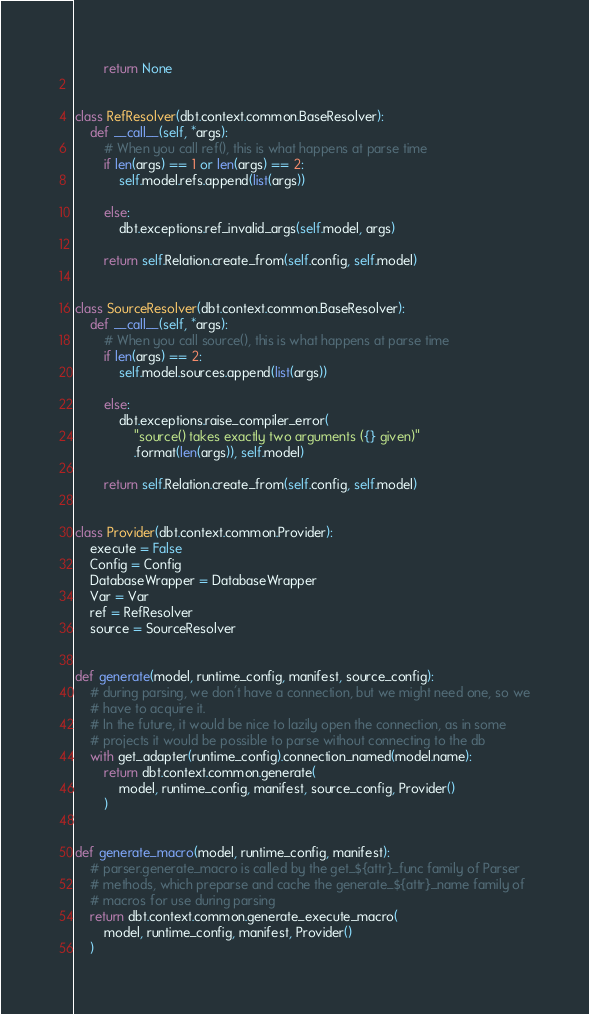Convert code to text. <code><loc_0><loc_0><loc_500><loc_500><_Python_>        return None


class RefResolver(dbt.context.common.BaseResolver):
    def __call__(self, *args):
        # When you call ref(), this is what happens at parse time
        if len(args) == 1 or len(args) == 2:
            self.model.refs.append(list(args))

        else:
            dbt.exceptions.ref_invalid_args(self.model, args)

        return self.Relation.create_from(self.config, self.model)


class SourceResolver(dbt.context.common.BaseResolver):
    def __call__(self, *args):
        # When you call source(), this is what happens at parse time
        if len(args) == 2:
            self.model.sources.append(list(args))

        else:
            dbt.exceptions.raise_compiler_error(
                "source() takes exactly two arguments ({} given)"
                .format(len(args)), self.model)

        return self.Relation.create_from(self.config, self.model)


class Provider(dbt.context.common.Provider):
    execute = False
    Config = Config
    DatabaseWrapper = DatabaseWrapper
    Var = Var
    ref = RefResolver
    source = SourceResolver


def generate(model, runtime_config, manifest, source_config):
    # during parsing, we don't have a connection, but we might need one, so we
    # have to acquire it.
    # In the future, it would be nice to lazily open the connection, as in some
    # projects it would be possible to parse without connecting to the db
    with get_adapter(runtime_config).connection_named(model.name):
        return dbt.context.common.generate(
            model, runtime_config, manifest, source_config, Provider()
        )


def generate_macro(model, runtime_config, manifest):
    # parser.generate_macro is called by the get_${attr}_func family of Parser
    # methods, which preparse and cache the generate_${attr}_name family of
    # macros for use during parsing
    return dbt.context.common.generate_execute_macro(
        model, runtime_config, manifest, Provider()
    )
</code> 